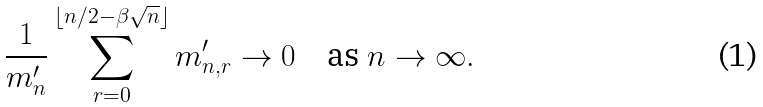Convert formula to latex. <formula><loc_0><loc_0><loc_500><loc_500>\frac { 1 } { m ^ { \prime } _ { n } } \sum _ { r = 0 } ^ { \lfloor n / 2 - \beta \sqrt { n } \rfloor } m ^ { \prime } _ { n , r } \to 0 \quad \text {as $n \to \infty$} .</formula> 